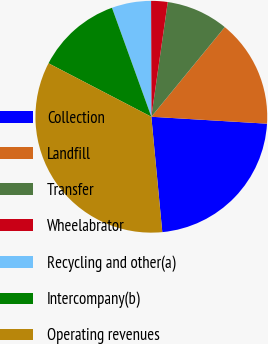Convert chart. <chart><loc_0><loc_0><loc_500><loc_500><pie_chart><fcel>Collection<fcel>Landfill<fcel>Transfer<fcel>Wheelabrator<fcel>Recycling and other(a)<fcel>Intercompany(b)<fcel>Operating revenues<nl><fcel>22.54%<fcel>15.03%<fcel>8.66%<fcel>2.3%<fcel>5.48%<fcel>11.85%<fcel>34.14%<nl></chart> 